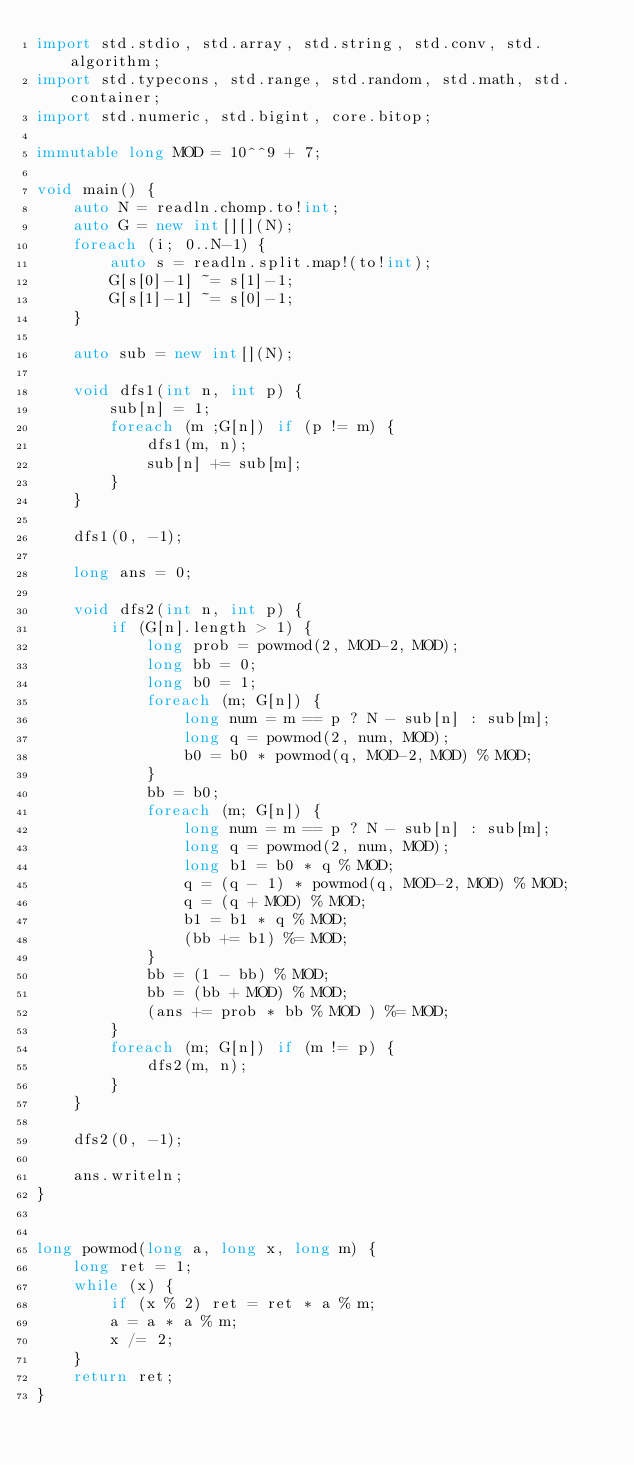Convert code to text. <code><loc_0><loc_0><loc_500><loc_500><_D_>import std.stdio, std.array, std.string, std.conv, std.algorithm;
import std.typecons, std.range, std.random, std.math, std.container;
import std.numeric, std.bigint, core.bitop;

immutable long MOD = 10^^9 + 7;

void main() {
    auto N = readln.chomp.to!int;
    auto G = new int[][](N);
    foreach (i; 0..N-1) {
        auto s = readln.split.map!(to!int);
        G[s[0]-1] ~= s[1]-1;
        G[s[1]-1] ~= s[0]-1;
    }

    auto sub = new int[](N);

    void dfs1(int n, int p) {
        sub[n] = 1;
        foreach (m ;G[n]) if (p != m) {
            dfs1(m, n);
            sub[n] += sub[m];
        }
    }

    dfs1(0, -1);

    long ans = 0;

    void dfs2(int n, int p) {
        if (G[n].length > 1) {
            long prob = powmod(2, MOD-2, MOD);
            long bb = 0;
            long b0 = 1;
            foreach (m; G[n]) {
                long num = m == p ? N - sub[n] : sub[m];
                long q = powmod(2, num, MOD);
                b0 = b0 * powmod(q, MOD-2, MOD) % MOD;
            }
            bb = b0;
            foreach (m; G[n]) {
                long num = m == p ? N - sub[n] : sub[m];
                long q = powmod(2, num, MOD);
                long b1 = b0 * q % MOD;
                q = (q - 1) * powmod(q, MOD-2, MOD) % MOD;
                q = (q + MOD) % MOD;
                b1 = b1 * q % MOD;
                (bb += b1) %= MOD;
            }
            bb = (1 - bb) % MOD;
            bb = (bb + MOD) % MOD;
            (ans += prob * bb % MOD ) %= MOD;
        }
        foreach (m; G[n]) if (m != p) {
            dfs2(m, n);
        }
    }

    dfs2(0, -1);

    ans.writeln;
}


long powmod(long a, long x, long m) {
    long ret = 1;
    while (x) {
        if (x % 2) ret = ret * a % m;
        a = a * a % m;
        x /= 2;
    }
    return ret;
}
</code> 